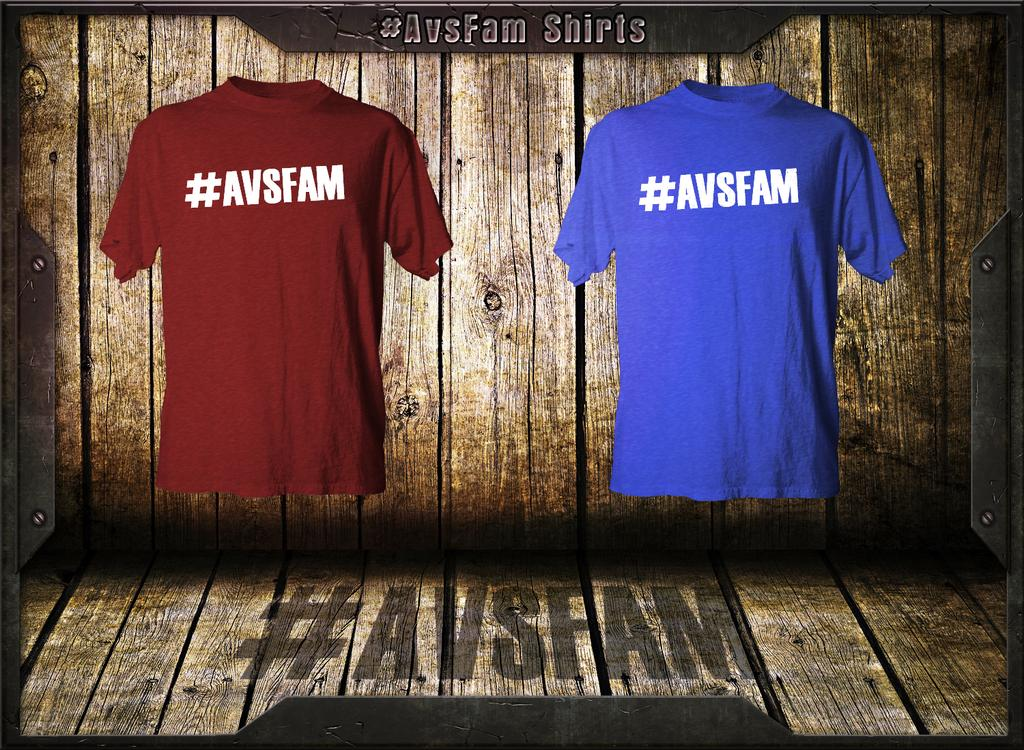<image>
Share a concise interpretation of the image provided. One red and one blue T-shirt with #AVSFAM on the front. 